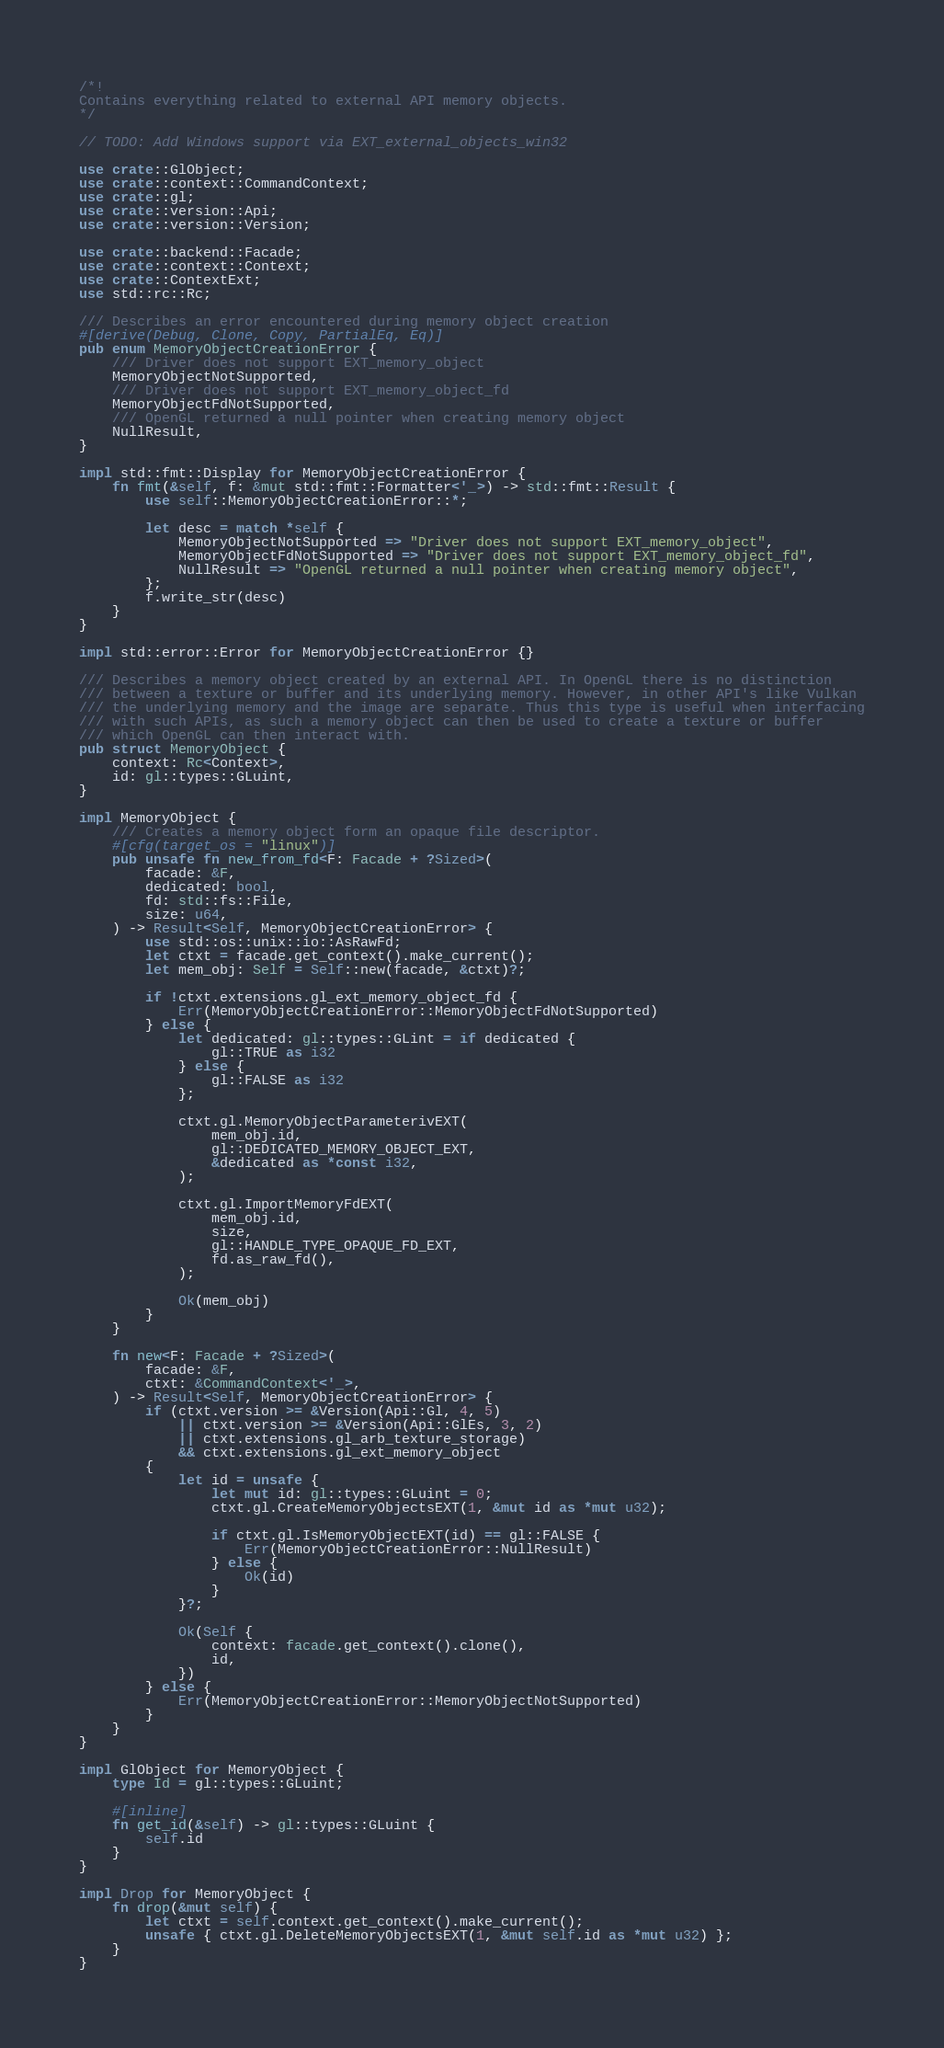Convert code to text. <code><loc_0><loc_0><loc_500><loc_500><_Rust_>/*!
Contains everything related to external API memory objects.
*/

// TODO: Add Windows support via EXT_external_objects_win32

use crate::GlObject;
use crate::context::CommandContext;
use crate::gl;
use crate::version::Api;
use crate::version::Version;

use crate::backend::Facade;
use crate::context::Context;
use crate::ContextExt;
use std::rc::Rc;

/// Describes an error encountered during memory object creation
#[derive(Debug, Clone, Copy, PartialEq, Eq)]
pub enum MemoryObjectCreationError {
    /// Driver does not support EXT_memory_object
    MemoryObjectNotSupported,
    /// Driver does not support EXT_memory_object_fd
    MemoryObjectFdNotSupported,
    /// OpenGL returned a null pointer when creating memory object
    NullResult,
}

impl std::fmt::Display for MemoryObjectCreationError {
    fn fmt(&self, f: &mut std::fmt::Formatter<'_>) -> std::fmt::Result {
        use self::MemoryObjectCreationError::*;

        let desc = match *self {
            MemoryObjectNotSupported => "Driver does not support EXT_memory_object",
            MemoryObjectFdNotSupported => "Driver does not support EXT_memory_object_fd",
            NullResult => "OpenGL returned a null pointer when creating memory object",
        };
        f.write_str(desc)
    }
}

impl std::error::Error for MemoryObjectCreationError {}

/// Describes a memory object created by an external API. In OpenGL there is no distinction
/// between a texture or buffer and its underlying memory. However, in other API's like Vulkan
/// the underlying memory and the image are separate. Thus this type is useful when interfacing
/// with such APIs, as such a memory object can then be used to create a texture or buffer
/// which OpenGL can then interact with.
pub struct MemoryObject {
    context: Rc<Context>,
    id: gl::types::GLuint,
}

impl MemoryObject {
    /// Creates a memory object form an opaque file descriptor.
    #[cfg(target_os = "linux")]
    pub unsafe fn new_from_fd<F: Facade + ?Sized>(
        facade: &F,
        dedicated: bool,
        fd: std::fs::File,
        size: u64,
    ) -> Result<Self, MemoryObjectCreationError> {
        use std::os::unix::io::AsRawFd;
        let ctxt = facade.get_context().make_current();
        let mem_obj: Self = Self::new(facade, &ctxt)?;

        if !ctxt.extensions.gl_ext_memory_object_fd {
            Err(MemoryObjectCreationError::MemoryObjectFdNotSupported)
        } else {
            let dedicated: gl::types::GLint = if dedicated {
                gl::TRUE as i32
            } else {
                gl::FALSE as i32
            };

            ctxt.gl.MemoryObjectParameterivEXT(
                mem_obj.id,
                gl::DEDICATED_MEMORY_OBJECT_EXT,
                &dedicated as *const i32,
            );

            ctxt.gl.ImportMemoryFdEXT(
                mem_obj.id,
                size,
                gl::HANDLE_TYPE_OPAQUE_FD_EXT,
                fd.as_raw_fd(),
            );

            Ok(mem_obj)
        }
    }

    fn new<F: Facade + ?Sized>(
        facade: &F,
        ctxt: &CommandContext<'_>,
    ) -> Result<Self, MemoryObjectCreationError> {
        if (ctxt.version >= &Version(Api::Gl, 4, 5)
            || ctxt.version >= &Version(Api::GlEs, 3, 2)
            || ctxt.extensions.gl_arb_texture_storage)
            && ctxt.extensions.gl_ext_memory_object
        {
            let id = unsafe {
                let mut id: gl::types::GLuint = 0;
                ctxt.gl.CreateMemoryObjectsEXT(1, &mut id as *mut u32);

                if ctxt.gl.IsMemoryObjectEXT(id) == gl::FALSE {
                    Err(MemoryObjectCreationError::NullResult)
                } else {
                    Ok(id)
                }
            }?;

            Ok(Self {
                context: facade.get_context().clone(),
                id,
            })
        } else {
            Err(MemoryObjectCreationError::MemoryObjectNotSupported)
        }
    }
}

impl GlObject for MemoryObject {
    type Id = gl::types::GLuint;

    #[inline]
    fn get_id(&self) -> gl::types::GLuint {
        self.id
    }
}

impl Drop for MemoryObject {
    fn drop(&mut self) {
        let ctxt = self.context.get_context().make_current();
        unsafe { ctxt.gl.DeleteMemoryObjectsEXT(1, &mut self.id as *mut u32) };
    }
}
</code> 